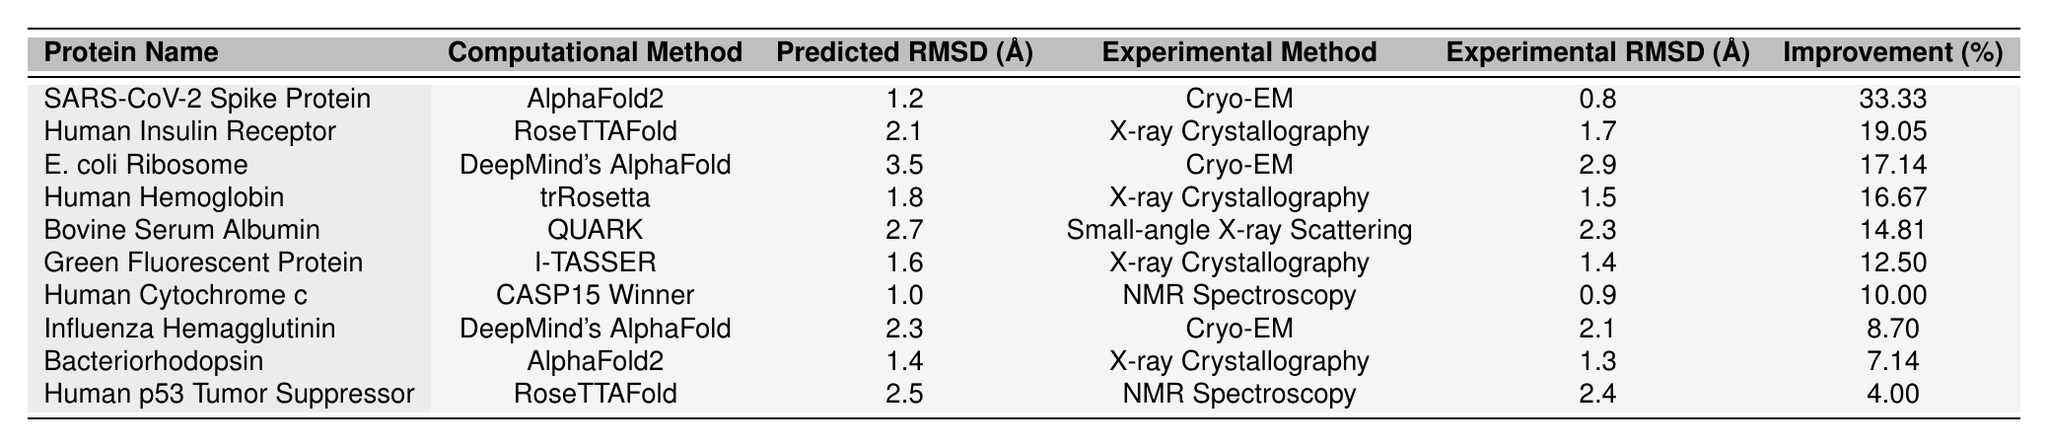What is the structural RMSD of the SARS-CoV-2 Spike Protein predicted by AlphaFold2? From the table, the predicted RMSD for the SARS-CoV-2 Spike Protein is listed as 1.2 Å.
Answer: 1.2 Å Which protein has the highest accuracy improvement percentage based on the table? The table shows that the SARS-CoV-2 Spike Protein has the highest accuracy improvement of 33.33%.
Answer: SARS-CoV-2 Spike Protein What are the experimental methods used for the Human Insulin Receptor? The table indicates that the experimental method used for the Human Insulin Receptor is X-ray Crystallography.
Answer: X-ray Crystallography Is the predicted structure RMSD for Human p53 Tumor Suppressor greater than 2.0 Å? By checking the table, the predicted structure RMSD for Human p53 Tumor Suppressor is 2.5 Å, which is greater than 2.0 Å.
Answer: Yes What is the average accuracy improvement percentage for proteins using AlphaFold2? To find the average accuracy improvement for AlphaFold2, add the improvements: 33.33% (SARS-CoV-2) + 7.14% (Bacteriorhodopsin) = 40.47%. Then, divide by 2 (the number of AlphaFold2 proteins): 40.47% / 2 = 20.235%.
Answer: 20.235% Which protein has a predicted RMSD closest to its experimental RMSD? Comparing the RMSD values, the Human Cytochrome c has a predicted RMSD of 1.0 Å and an experimental RMSD of 0.9 Å, so the difference is the smallest.
Answer: Human Cytochrome c What is the difference between the predicted RMSD and experimental RMSD for E. coli Ribosome? For E. coli Ribosome, the predicted RMSD is 3.5 Å and the experimental RMSD is 2.9 Å. The difference is calculated as 3.5 - 2.9 = 0.6 Å.
Answer: 0.6 Å Are all experimental methods listed in the table different from each other? The experimental methods used include Cryo-EM, X-ray Crystallography, Small-angle X-ray Scattering, and NMR Spectroscopy. Since Cryo-EM is repeated, not all methods are different.
Answer: No Which computational method has the lowest predicted structure RMSD? By inspecting the table, the computational method with the lowest predicted RMSD is CASP15 Winner for Human Cytochrome c, at 1.0 Å.
Answer: CASP15 Winner Calculate the percentage of proteins tested using X-ray Crystallography out of the total listed. In the table, 4 out of 10 proteins are tested using X-ray Crystallography. The percentage is calculated as (4/10) * 100 = 40%.
Answer: 40% 